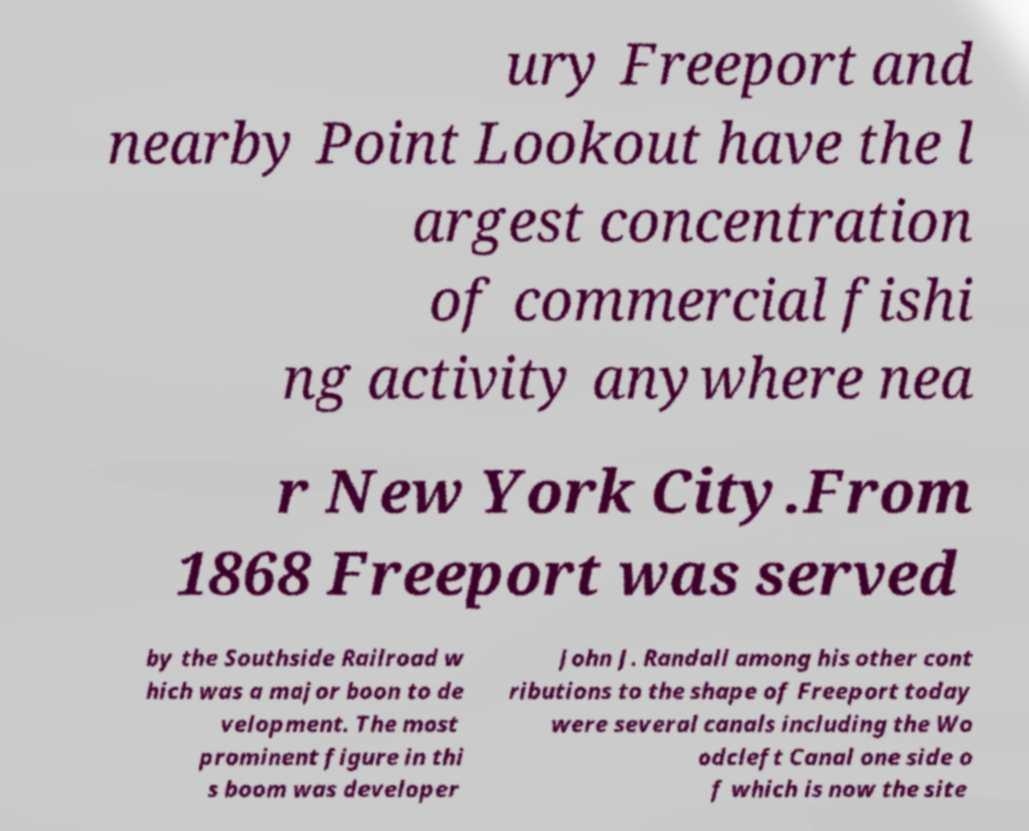Can you read and provide the text displayed in the image?This photo seems to have some interesting text. Can you extract and type it out for me? ury Freeport and nearby Point Lookout have the l argest concentration of commercial fishi ng activity anywhere nea r New York City.From 1868 Freeport was served by the Southside Railroad w hich was a major boon to de velopment. The most prominent figure in thi s boom was developer John J. Randall among his other cont ributions to the shape of Freeport today were several canals including the Wo odcleft Canal one side o f which is now the site 